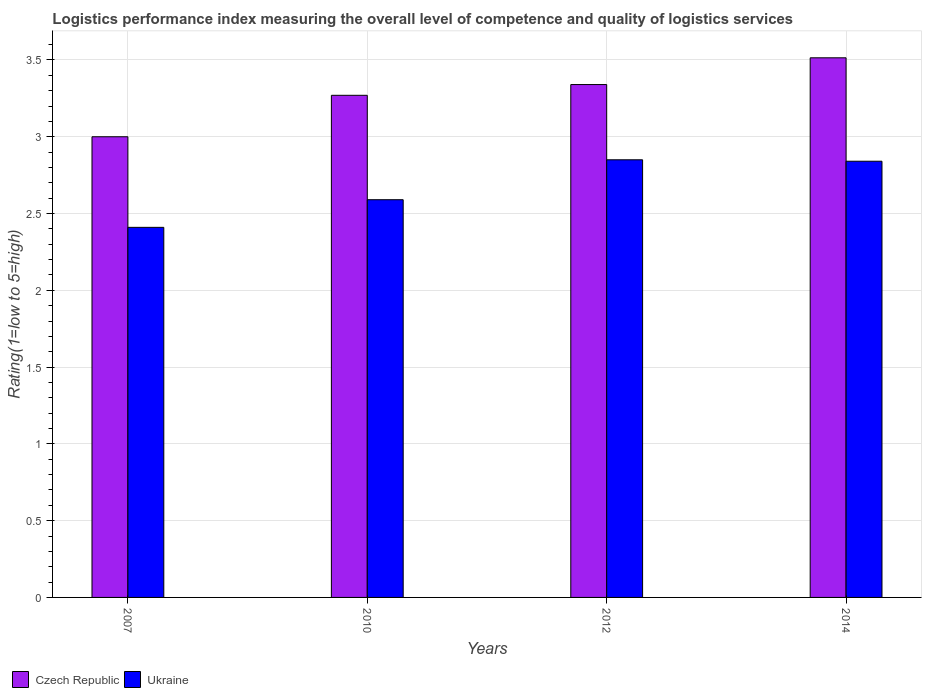How many bars are there on the 3rd tick from the right?
Provide a short and direct response. 2. What is the label of the 2nd group of bars from the left?
Make the answer very short. 2010. In how many cases, is the number of bars for a given year not equal to the number of legend labels?
Your answer should be compact. 0. What is the Logistic performance index in Ukraine in 2007?
Ensure brevity in your answer.  2.41. Across all years, what is the maximum Logistic performance index in Ukraine?
Provide a succinct answer. 2.85. Across all years, what is the minimum Logistic performance index in Czech Republic?
Your answer should be compact. 3. In which year was the Logistic performance index in Czech Republic minimum?
Your response must be concise. 2007. What is the total Logistic performance index in Czech Republic in the graph?
Offer a very short reply. 13.12. What is the difference between the Logistic performance index in Czech Republic in 2007 and that in 2014?
Provide a succinct answer. -0.51. What is the difference between the Logistic performance index in Czech Republic in 2010 and the Logistic performance index in Ukraine in 2012?
Keep it short and to the point. 0.42. What is the average Logistic performance index in Czech Republic per year?
Give a very brief answer. 3.28. In the year 2012, what is the difference between the Logistic performance index in Ukraine and Logistic performance index in Czech Republic?
Ensure brevity in your answer.  -0.49. What is the ratio of the Logistic performance index in Czech Republic in 2007 to that in 2010?
Provide a succinct answer. 0.92. Is the difference between the Logistic performance index in Ukraine in 2012 and 2014 greater than the difference between the Logistic performance index in Czech Republic in 2012 and 2014?
Offer a terse response. Yes. What is the difference between the highest and the second highest Logistic performance index in Ukraine?
Ensure brevity in your answer.  0.01. What is the difference between the highest and the lowest Logistic performance index in Czech Republic?
Offer a very short reply. 0.51. In how many years, is the Logistic performance index in Ukraine greater than the average Logistic performance index in Ukraine taken over all years?
Ensure brevity in your answer.  2. What does the 1st bar from the left in 2014 represents?
Offer a very short reply. Czech Republic. What does the 1st bar from the right in 2012 represents?
Offer a terse response. Ukraine. How many bars are there?
Ensure brevity in your answer.  8. Are all the bars in the graph horizontal?
Your answer should be compact. No. Are the values on the major ticks of Y-axis written in scientific E-notation?
Offer a terse response. No. Does the graph contain any zero values?
Give a very brief answer. No. Does the graph contain grids?
Provide a succinct answer. Yes. How are the legend labels stacked?
Provide a short and direct response. Horizontal. What is the title of the graph?
Your answer should be very brief. Logistics performance index measuring the overall level of competence and quality of logistics services. Does "Sierra Leone" appear as one of the legend labels in the graph?
Provide a short and direct response. No. What is the label or title of the Y-axis?
Your response must be concise. Rating(1=low to 5=high). What is the Rating(1=low to 5=high) of Ukraine in 2007?
Your response must be concise. 2.41. What is the Rating(1=low to 5=high) of Czech Republic in 2010?
Your answer should be very brief. 3.27. What is the Rating(1=low to 5=high) in Ukraine in 2010?
Offer a terse response. 2.59. What is the Rating(1=low to 5=high) of Czech Republic in 2012?
Your response must be concise. 3.34. What is the Rating(1=low to 5=high) in Ukraine in 2012?
Offer a terse response. 2.85. What is the Rating(1=low to 5=high) of Czech Republic in 2014?
Keep it short and to the point. 3.51. What is the Rating(1=low to 5=high) of Ukraine in 2014?
Your answer should be compact. 2.84. Across all years, what is the maximum Rating(1=low to 5=high) in Czech Republic?
Your answer should be compact. 3.51. Across all years, what is the maximum Rating(1=low to 5=high) of Ukraine?
Your answer should be very brief. 2.85. Across all years, what is the minimum Rating(1=low to 5=high) in Czech Republic?
Offer a terse response. 3. Across all years, what is the minimum Rating(1=low to 5=high) in Ukraine?
Make the answer very short. 2.41. What is the total Rating(1=low to 5=high) in Czech Republic in the graph?
Provide a succinct answer. 13.12. What is the total Rating(1=low to 5=high) of Ukraine in the graph?
Offer a very short reply. 10.69. What is the difference between the Rating(1=low to 5=high) of Czech Republic in 2007 and that in 2010?
Your response must be concise. -0.27. What is the difference between the Rating(1=low to 5=high) in Ukraine in 2007 and that in 2010?
Keep it short and to the point. -0.18. What is the difference between the Rating(1=low to 5=high) of Czech Republic in 2007 and that in 2012?
Offer a very short reply. -0.34. What is the difference between the Rating(1=low to 5=high) of Ukraine in 2007 and that in 2012?
Keep it short and to the point. -0.44. What is the difference between the Rating(1=low to 5=high) in Czech Republic in 2007 and that in 2014?
Provide a succinct answer. -0.51. What is the difference between the Rating(1=low to 5=high) of Ukraine in 2007 and that in 2014?
Offer a terse response. -0.43. What is the difference between the Rating(1=low to 5=high) in Czech Republic in 2010 and that in 2012?
Offer a very short reply. -0.07. What is the difference between the Rating(1=low to 5=high) in Ukraine in 2010 and that in 2012?
Keep it short and to the point. -0.26. What is the difference between the Rating(1=low to 5=high) in Czech Republic in 2010 and that in 2014?
Keep it short and to the point. -0.24. What is the difference between the Rating(1=low to 5=high) of Ukraine in 2010 and that in 2014?
Your response must be concise. -0.25. What is the difference between the Rating(1=low to 5=high) in Czech Republic in 2012 and that in 2014?
Your answer should be very brief. -0.17. What is the difference between the Rating(1=low to 5=high) of Ukraine in 2012 and that in 2014?
Your response must be concise. 0.01. What is the difference between the Rating(1=low to 5=high) of Czech Republic in 2007 and the Rating(1=low to 5=high) of Ukraine in 2010?
Give a very brief answer. 0.41. What is the difference between the Rating(1=low to 5=high) of Czech Republic in 2007 and the Rating(1=low to 5=high) of Ukraine in 2012?
Offer a very short reply. 0.15. What is the difference between the Rating(1=low to 5=high) in Czech Republic in 2007 and the Rating(1=low to 5=high) in Ukraine in 2014?
Provide a succinct answer. 0.16. What is the difference between the Rating(1=low to 5=high) in Czech Republic in 2010 and the Rating(1=low to 5=high) in Ukraine in 2012?
Your response must be concise. 0.42. What is the difference between the Rating(1=low to 5=high) of Czech Republic in 2010 and the Rating(1=low to 5=high) of Ukraine in 2014?
Make the answer very short. 0.43. What is the difference between the Rating(1=low to 5=high) in Czech Republic in 2012 and the Rating(1=low to 5=high) in Ukraine in 2014?
Give a very brief answer. 0.5. What is the average Rating(1=low to 5=high) of Czech Republic per year?
Keep it short and to the point. 3.28. What is the average Rating(1=low to 5=high) of Ukraine per year?
Offer a terse response. 2.67. In the year 2007, what is the difference between the Rating(1=low to 5=high) in Czech Republic and Rating(1=low to 5=high) in Ukraine?
Your response must be concise. 0.59. In the year 2010, what is the difference between the Rating(1=low to 5=high) of Czech Republic and Rating(1=low to 5=high) of Ukraine?
Give a very brief answer. 0.68. In the year 2012, what is the difference between the Rating(1=low to 5=high) in Czech Republic and Rating(1=low to 5=high) in Ukraine?
Keep it short and to the point. 0.49. In the year 2014, what is the difference between the Rating(1=low to 5=high) in Czech Republic and Rating(1=low to 5=high) in Ukraine?
Offer a terse response. 0.67. What is the ratio of the Rating(1=low to 5=high) in Czech Republic in 2007 to that in 2010?
Give a very brief answer. 0.92. What is the ratio of the Rating(1=low to 5=high) in Ukraine in 2007 to that in 2010?
Offer a terse response. 0.93. What is the ratio of the Rating(1=low to 5=high) in Czech Republic in 2007 to that in 2012?
Offer a terse response. 0.9. What is the ratio of the Rating(1=low to 5=high) in Ukraine in 2007 to that in 2012?
Ensure brevity in your answer.  0.85. What is the ratio of the Rating(1=low to 5=high) in Czech Republic in 2007 to that in 2014?
Provide a short and direct response. 0.85. What is the ratio of the Rating(1=low to 5=high) of Ukraine in 2007 to that in 2014?
Ensure brevity in your answer.  0.85. What is the ratio of the Rating(1=low to 5=high) of Czech Republic in 2010 to that in 2012?
Offer a very short reply. 0.98. What is the ratio of the Rating(1=low to 5=high) of Ukraine in 2010 to that in 2012?
Give a very brief answer. 0.91. What is the ratio of the Rating(1=low to 5=high) of Czech Republic in 2010 to that in 2014?
Provide a short and direct response. 0.93. What is the ratio of the Rating(1=low to 5=high) in Ukraine in 2010 to that in 2014?
Offer a terse response. 0.91. What is the ratio of the Rating(1=low to 5=high) of Czech Republic in 2012 to that in 2014?
Give a very brief answer. 0.95. What is the ratio of the Rating(1=low to 5=high) in Ukraine in 2012 to that in 2014?
Keep it short and to the point. 1. What is the difference between the highest and the second highest Rating(1=low to 5=high) in Czech Republic?
Your answer should be very brief. 0.17. What is the difference between the highest and the second highest Rating(1=low to 5=high) of Ukraine?
Make the answer very short. 0.01. What is the difference between the highest and the lowest Rating(1=low to 5=high) in Czech Republic?
Ensure brevity in your answer.  0.51. What is the difference between the highest and the lowest Rating(1=low to 5=high) in Ukraine?
Your response must be concise. 0.44. 